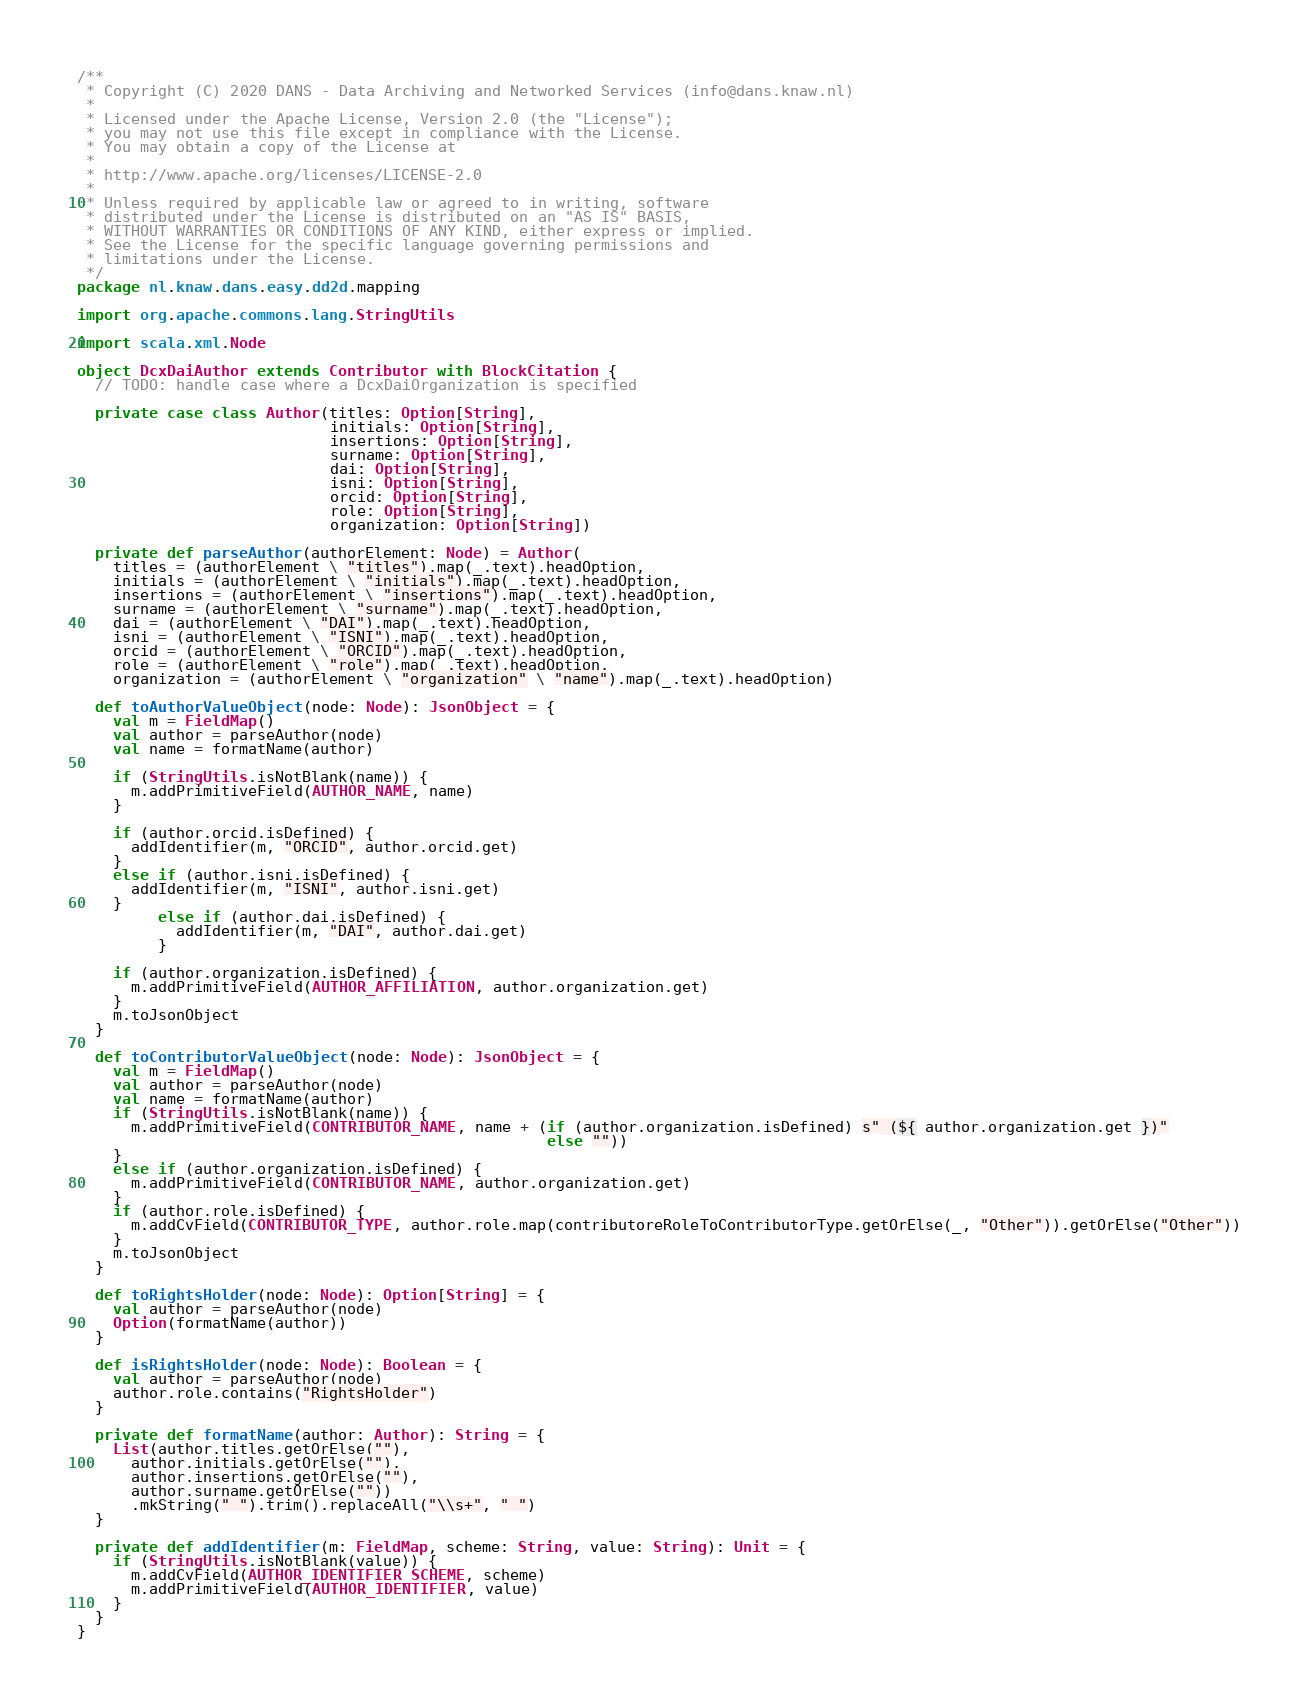Convert code to text. <code><loc_0><loc_0><loc_500><loc_500><_Scala_>/**
 * Copyright (C) 2020 DANS - Data Archiving and Networked Services (info@dans.knaw.nl)
 *
 * Licensed under the Apache License, Version 2.0 (the "License");
 * you may not use this file except in compliance with the License.
 * You may obtain a copy of the License at
 *
 * http://www.apache.org/licenses/LICENSE-2.0
 *
 * Unless required by applicable law or agreed to in writing, software
 * distributed under the License is distributed on an "AS IS" BASIS,
 * WITHOUT WARRANTIES OR CONDITIONS OF ANY KIND, either express or implied.
 * See the License for the specific language governing permissions and
 * limitations under the License.
 */
package nl.knaw.dans.easy.dd2d.mapping

import org.apache.commons.lang.StringUtils

import scala.xml.Node

object DcxDaiAuthor extends Contributor with BlockCitation {
  // TODO: handle case where a DcxDaiOrganization is specified

  private case class Author(titles: Option[String],
                            initials: Option[String],
                            insertions: Option[String],
                            surname: Option[String],
                            dai: Option[String],
                            isni: Option[String],
                            orcid: Option[String],
                            role: Option[String],
                            organization: Option[String])

  private def parseAuthor(authorElement: Node) = Author(
    titles = (authorElement \ "titles").map(_.text).headOption,
    initials = (authorElement \ "initials").map(_.text).headOption,
    insertions = (authorElement \ "insertions").map(_.text).headOption,
    surname = (authorElement \ "surname").map(_.text).headOption,
    dai = (authorElement \ "DAI").map(_.text).headOption,
    isni = (authorElement \ "ISNI").map(_.text).headOption,
    orcid = (authorElement \ "ORCID").map(_.text).headOption,
    role = (authorElement \ "role").map(_.text).headOption,
    organization = (authorElement \ "organization" \ "name").map(_.text).headOption)

  def toAuthorValueObject(node: Node): JsonObject = {
    val m = FieldMap()
    val author = parseAuthor(node)
    val name = formatName(author)

    if (StringUtils.isNotBlank(name)) {
      m.addPrimitiveField(AUTHOR_NAME, name)
    }

    if (author.orcid.isDefined) {
      addIdentifier(m, "ORCID", author.orcid.get)
    }
    else if (author.isni.isDefined) {
      addIdentifier(m, "ISNI", author.isni.get)
    }
         else if (author.dai.isDefined) {
           addIdentifier(m, "DAI", author.dai.get)
         }

    if (author.organization.isDefined) {
      m.addPrimitiveField(AUTHOR_AFFILIATION, author.organization.get)
    }
    m.toJsonObject
  }

  def toContributorValueObject(node: Node): JsonObject = {
    val m = FieldMap()
    val author = parseAuthor(node)
    val name = formatName(author)
    if (StringUtils.isNotBlank(name)) {
      m.addPrimitiveField(CONTRIBUTOR_NAME, name + (if (author.organization.isDefined) s" (${ author.organization.get })"
                                                    else ""))
    }
    else if (author.organization.isDefined) {
      m.addPrimitiveField(CONTRIBUTOR_NAME, author.organization.get)
    }
    if (author.role.isDefined) {
      m.addCvField(CONTRIBUTOR_TYPE, author.role.map(contributoreRoleToContributorType.getOrElse(_, "Other")).getOrElse("Other"))
    }
    m.toJsonObject
  }

  def toRightsHolder(node: Node): Option[String] = {
    val author = parseAuthor(node)
    Option(formatName(author))
  }

  def isRightsHolder(node: Node): Boolean = {
    val author = parseAuthor(node)
    author.role.contains("RightsHolder")
  }

  private def formatName(author: Author): String = {
    List(author.titles.getOrElse(""),
      author.initials.getOrElse(""),
      author.insertions.getOrElse(""),
      author.surname.getOrElse(""))
      .mkString(" ").trim().replaceAll("\\s+", " ")
  }

  private def addIdentifier(m: FieldMap, scheme: String, value: String): Unit = {
    if (StringUtils.isNotBlank(value)) {
      m.addCvField(AUTHOR_IDENTIFIER_SCHEME, scheme)
      m.addPrimitiveField(AUTHOR_IDENTIFIER, value)
    }
  }
}
</code> 